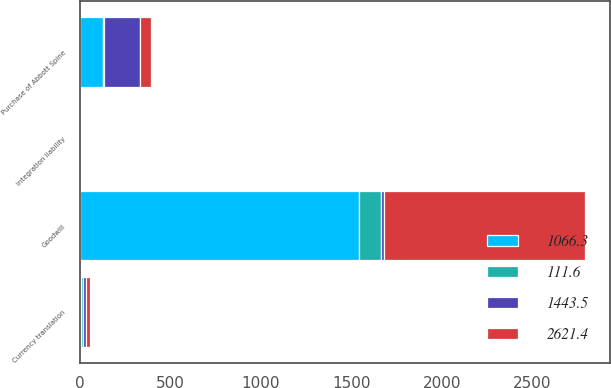<chart> <loc_0><loc_0><loc_500><loc_500><stacked_bar_chart><ecel><fcel>Purchase of Abbott Spine<fcel>Currency translation<fcel>Goodwill<fcel>Integration liability<nl><fcel>1066.3<fcel>129.3<fcel>5.9<fcel>1540.3<fcel>1<nl><fcel>2621.4<fcel>65.7<fcel>20.4<fcel>1110.1<fcel>4.2<nl><fcel>111.6<fcel>2.4<fcel>10.4<fcel>124.4<fcel>0.3<nl><fcel>1443.5<fcel>197.4<fcel>15.9<fcel>15.9<fcel>5.5<nl></chart> 